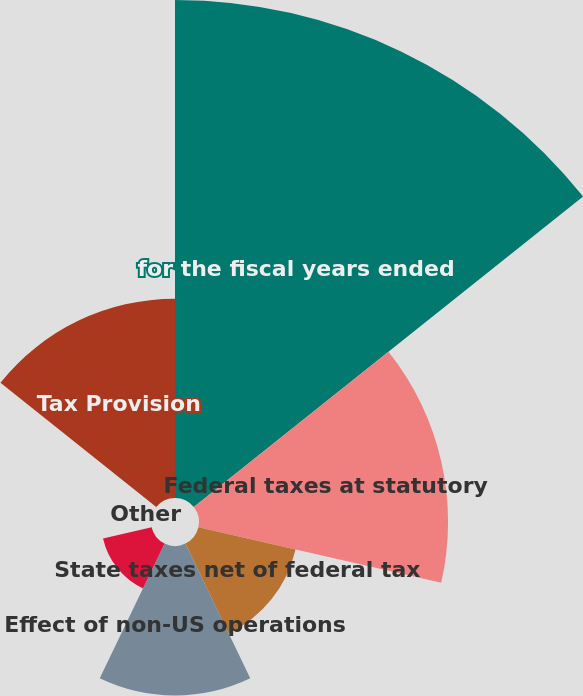<chart> <loc_0><loc_0><loc_500><loc_500><pie_chart><fcel>for the fiscal years ended<fcel>Federal taxes at statutory<fcel>State taxes net of federal tax<fcel>Effect of non-US operations<fcel>Effect of net loss (income)<fcel>Other<fcel>Tax Provision<nl><fcel>39.99%<fcel>20.0%<fcel>8.0%<fcel>12.0%<fcel>4.0%<fcel>0.01%<fcel>16.0%<nl></chart> 